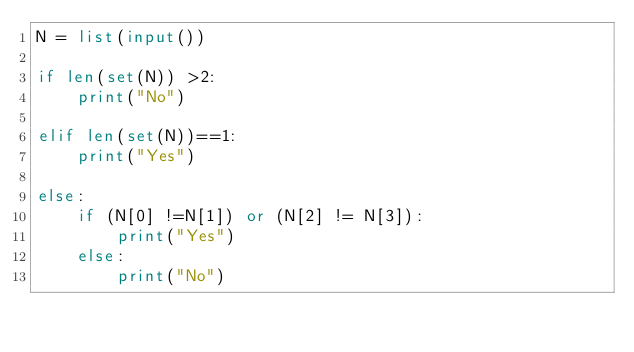Convert code to text. <code><loc_0><loc_0><loc_500><loc_500><_Python_>N = list(input())

if len(set(N)) >2:
    print("No")

elif len(set(N))==1:
    print("Yes")

else:
    if (N[0] !=N[1]) or (N[2] != N[3]):
        print("Yes")
    else:
        print("No")</code> 